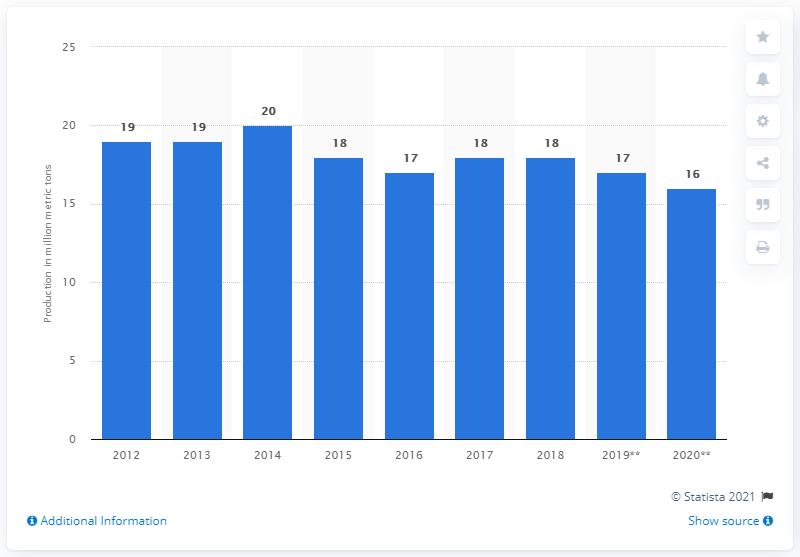Outline some significant characteristics in this image. The United States produced approximately 16 million metric tons of lime in 2020. 